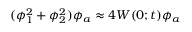<formula> <loc_0><loc_0><loc_500><loc_500>( \phi _ { 1 } ^ { 2 } + \phi _ { 2 } ^ { 2 } ) \phi _ { a } \approx 4 W ( 0 ; t ) \phi _ { a }</formula> 